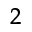<formula> <loc_0><loc_0><loc_500><loc_500>^ { 2 }</formula> 